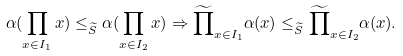Convert formula to latex. <formula><loc_0><loc_0><loc_500><loc_500>\alpha ( \prod _ { x \in I _ { 1 } } x ) \leq _ { \widetilde { S } } \alpha ( \prod _ { x \in I _ { 2 } } x ) \Rightarrow \widetilde { \prod } _ { x \in I _ { 1 } } \alpha ( x ) \leq _ { \widetilde { S } } \widetilde { \prod } _ { x \in I _ { 2 } } \alpha ( x ) .</formula> 